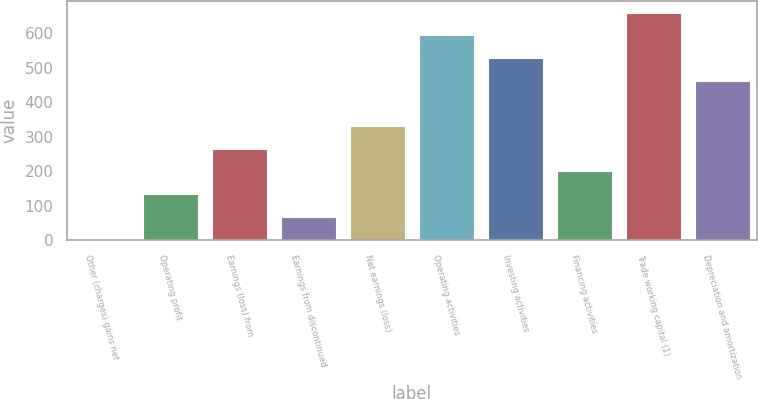Convert chart. <chart><loc_0><loc_0><loc_500><loc_500><bar_chart><fcel>Other (charges) gains net<fcel>Operating profit<fcel>Earnings (loss) from<fcel>Earnings from discontinued<fcel>Net earnings (loss)<fcel>Operating activities<fcel>Investing activities<fcel>Financing activities<fcel>Trade working capital (1)<fcel>Depreciation and amortization<nl><fcel>3<fcel>134.2<fcel>265.4<fcel>68.6<fcel>331<fcel>593.4<fcel>527.8<fcel>199.8<fcel>659<fcel>462.2<nl></chart> 